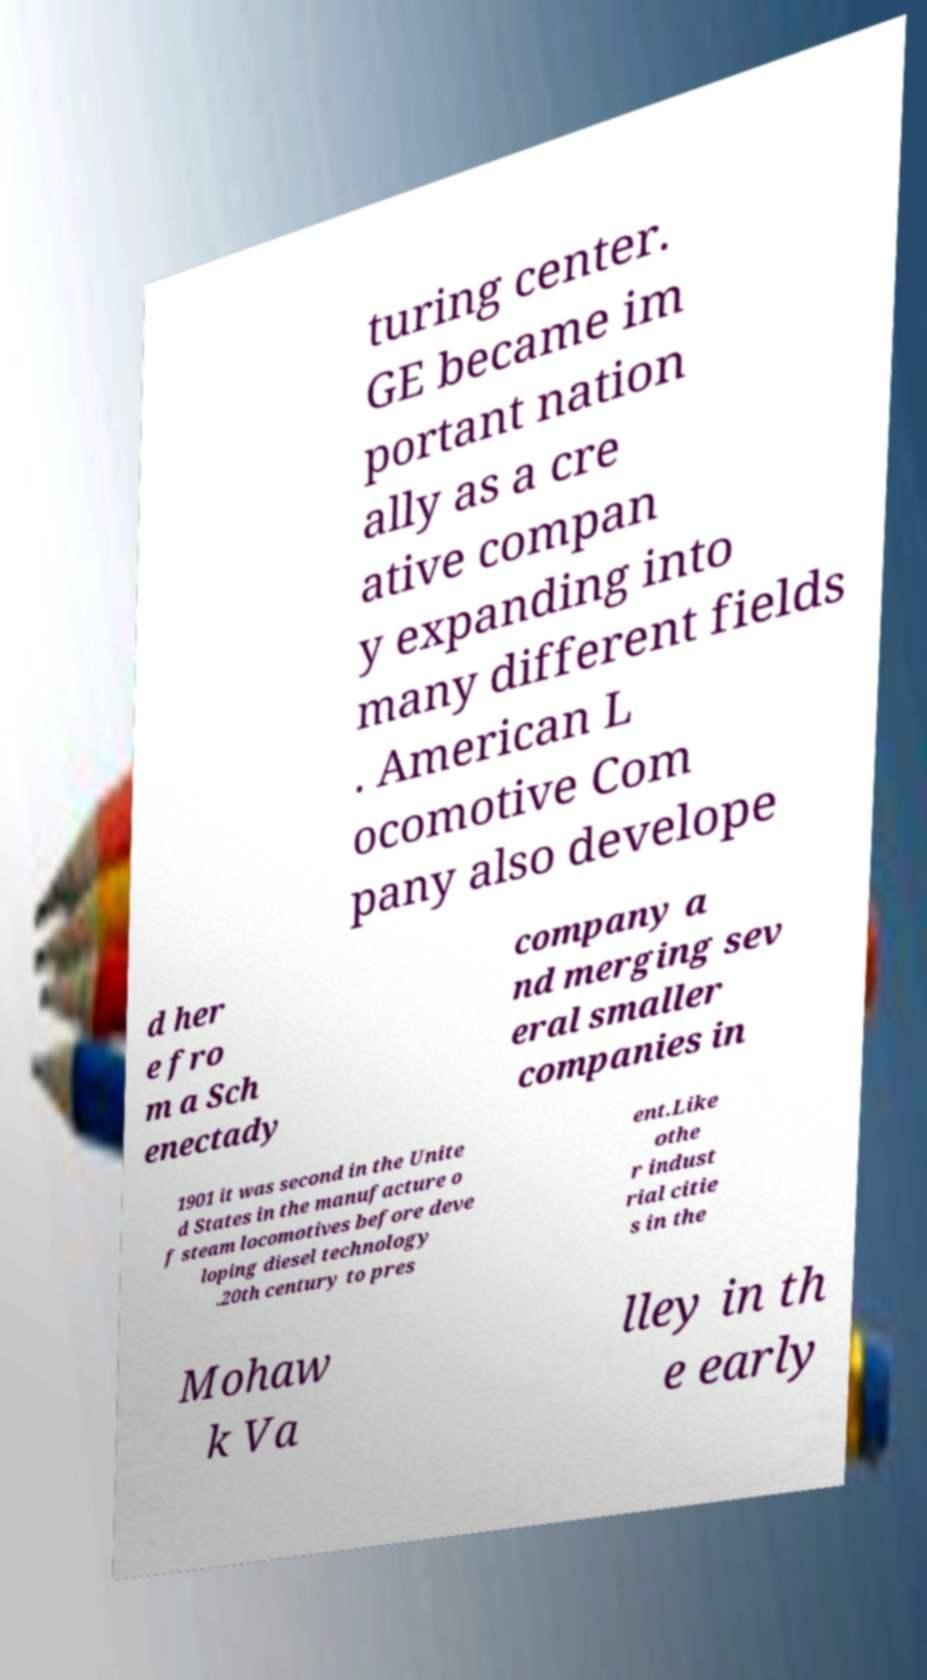There's text embedded in this image that I need extracted. Can you transcribe it verbatim? turing center. GE became im portant nation ally as a cre ative compan y expanding into many different fields . American L ocomotive Com pany also develope d her e fro m a Sch enectady company a nd merging sev eral smaller companies in 1901 it was second in the Unite d States in the manufacture o f steam locomotives before deve loping diesel technology .20th century to pres ent.Like othe r indust rial citie s in the Mohaw k Va lley in th e early 